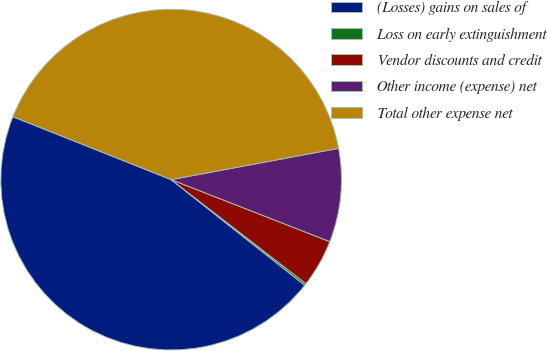<chart> <loc_0><loc_0><loc_500><loc_500><pie_chart><fcel>(Losses) gains on sales of<fcel>Loss on early extinguishment<fcel>Vendor discounts and credit<fcel>Other income (expense) net<fcel>Total other expense net<nl><fcel>45.37%<fcel>0.19%<fcel>4.53%<fcel>8.87%<fcel>41.03%<nl></chart> 